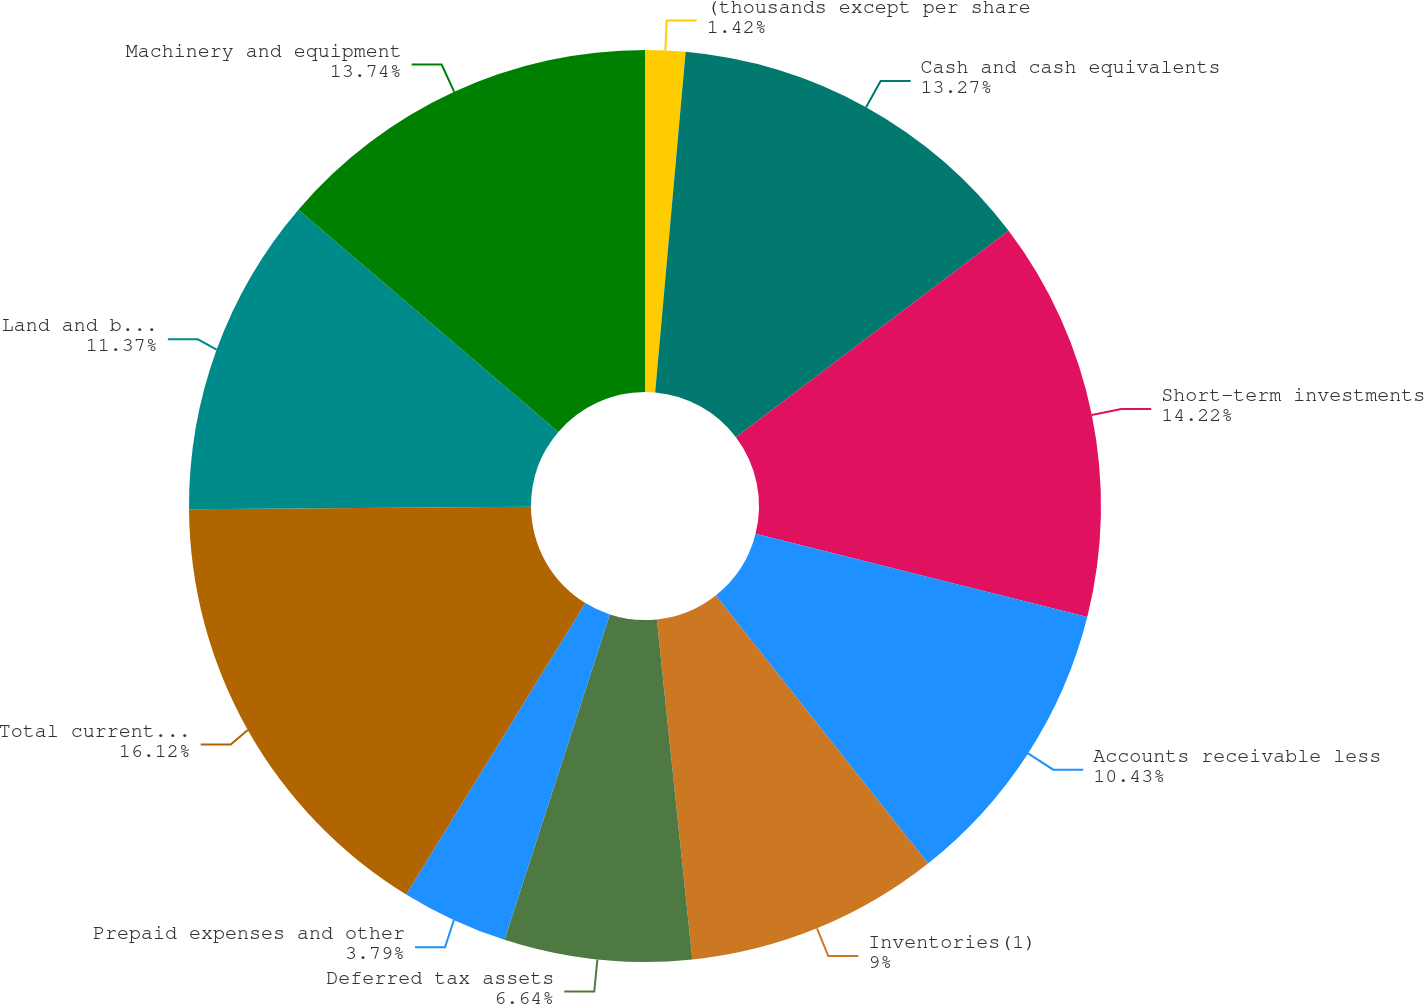Convert chart to OTSL. <chart><loc_0><loc_0><loc_500><loc_500><pie_chart><fcel>(thousands except per share<fcel>Cash and cash equivalents<fcel>Short-term investments<fcel>Accounts receivable less<fcel>Inventories(1)<fcel>Deferred tax assets<fcel>Prepaid expenses and other<fcel>Total current assets<fcel>Land and buildings<fcel>Machinery and equipment<nl><fcel>1.42%<fcel>13.27%<fcel>14.22%<fcel>10.43%<fcel>9.0%<fcel>6.64%<fcel>3.79%<fcel>16.11%<fcel>11.37%<fcel>13.74%<nl></chart> 